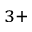<formula> <loc_0><loc_0><loc_500><loc_500>^ { 3 + }</formula> 